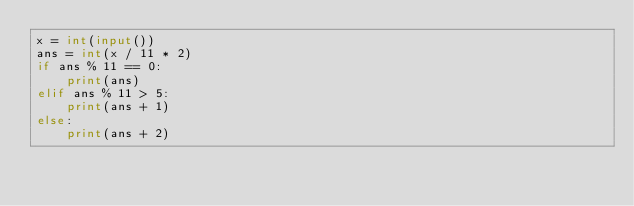Convert code to text. <code><loc_0><loc_0><loc_500><loc_500><_Python_>x = int(input())
ans = int(x / 11 * 2)
if ans % 11 == 0:
    print(ans)
elif ans % 11 > 5:
    print(ans + 1)
else:
    print(ans + 2)
    
</code> 